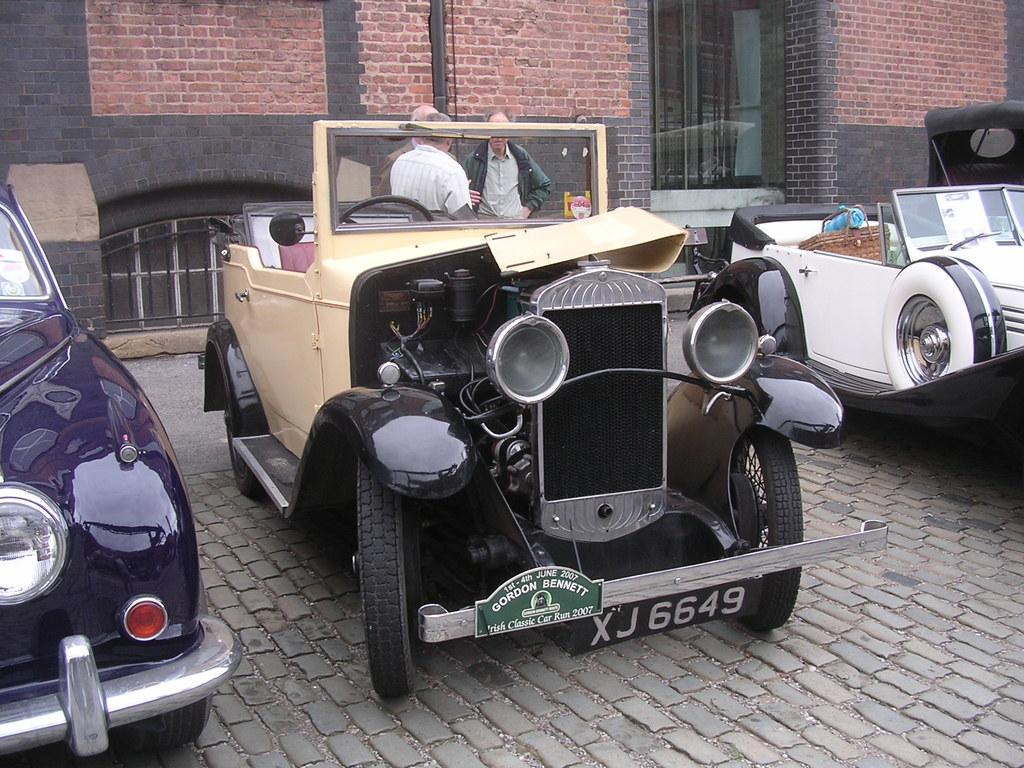What is the main subject in the center of the image? There are vehicles in the center of the image. What can be seen in the background of the image? There are people and buildings in the background of the image. What is the surface on which the vehicles are situated? There is a floor visible at the bottom of the image. What type of rhythm can be heard coming from the corn in the image? There is no corn present in the image, so there is no rhythm to be heard. 